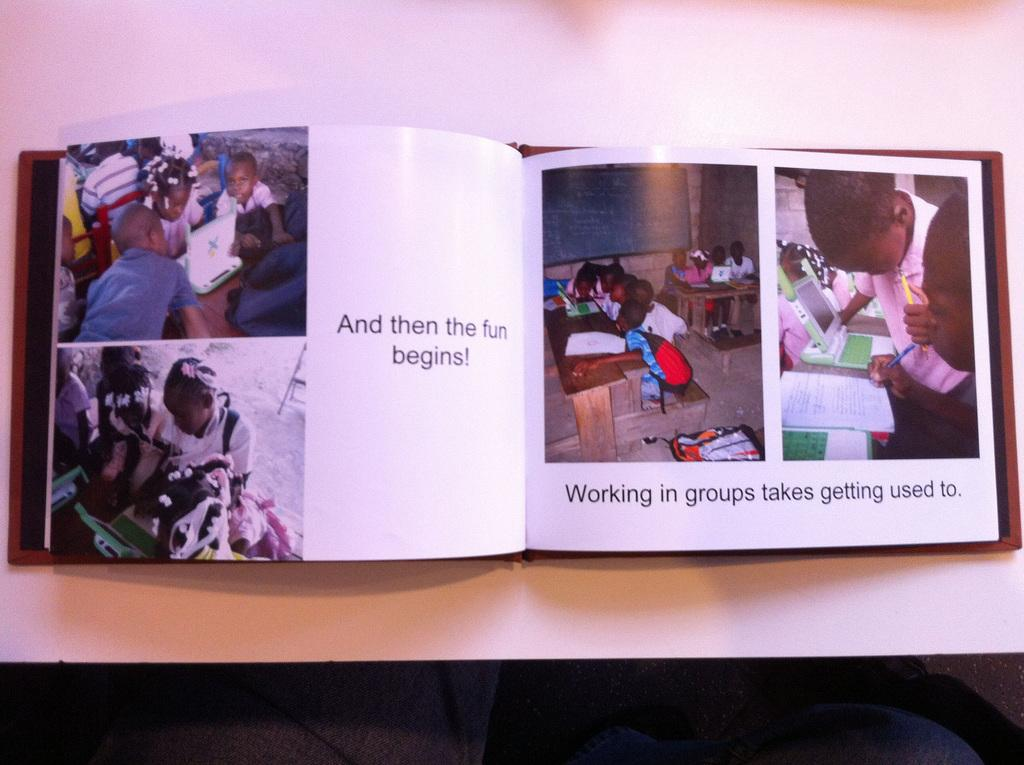Provide a one-sentence caption for the provided image. A book is open to children with the caption "And then the fun Begins!". 